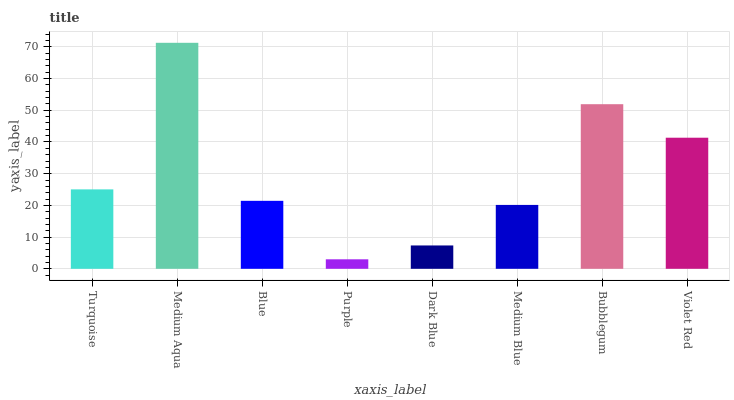Is Blue the minimum?
Answer yes or no. No. Is Blue the maximum?
Answer yes or no. No. Is Medium Aqua greater than Blue?
Answer yes or no. Yes. Is Blue less than Medium Aqua?
Answer yes or no. Yes. Is Blue greater than Medium Aqua?
Answer yes or no. No. Is Medium Aqua less than Blue?
Answer yes or no. No. Is Turquoise the high median?
Answer yes or no. Yes. Is Blue the low median?
Answer yes or no. Yes. Is Medium Blue the high median?
Answer yes or no. No. Is Violet Red the low median?
Answer yes or no. No. 